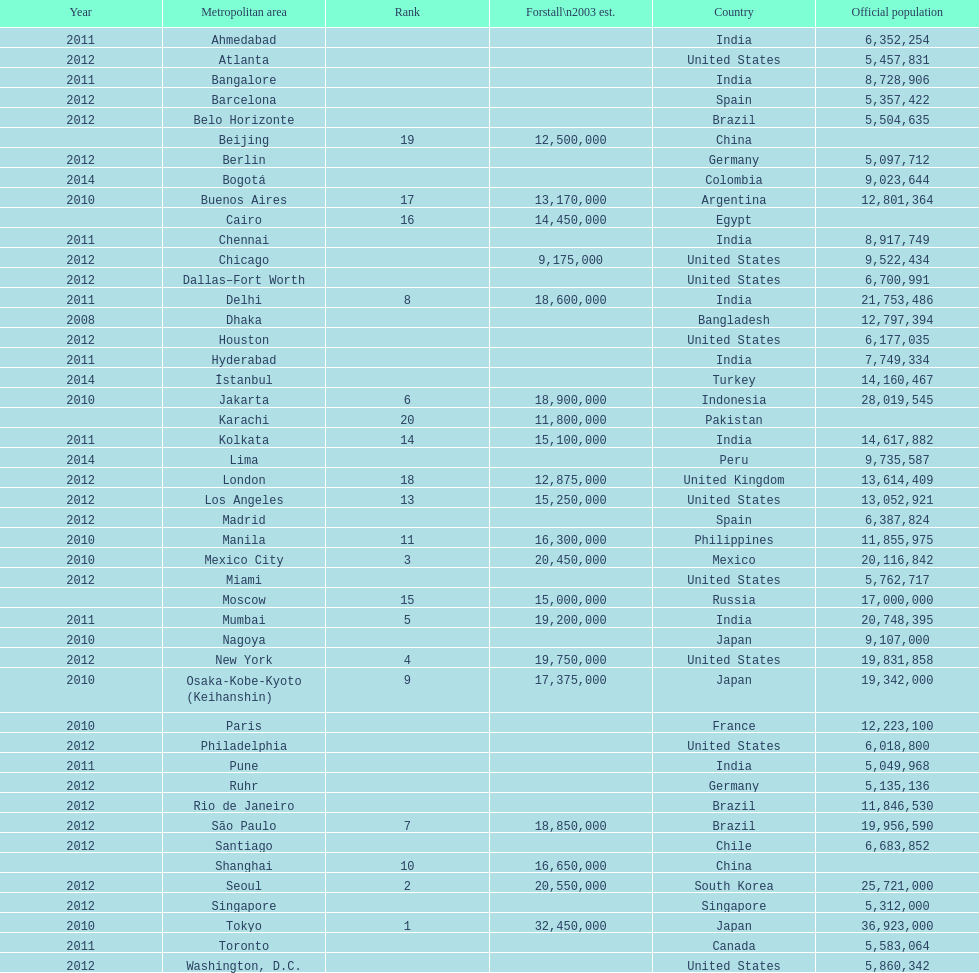Which areas had a population of more than 10,000,000 but less than 20,000,000? Buenos Aires, Dhaka, İstanbul, Kolkata, London, Los Angeles, Manila, Moscow, New York, Osaka-Kobe-Kyoto (Keihanshin), Paris, Rio de Janeiro, São Paulo. 